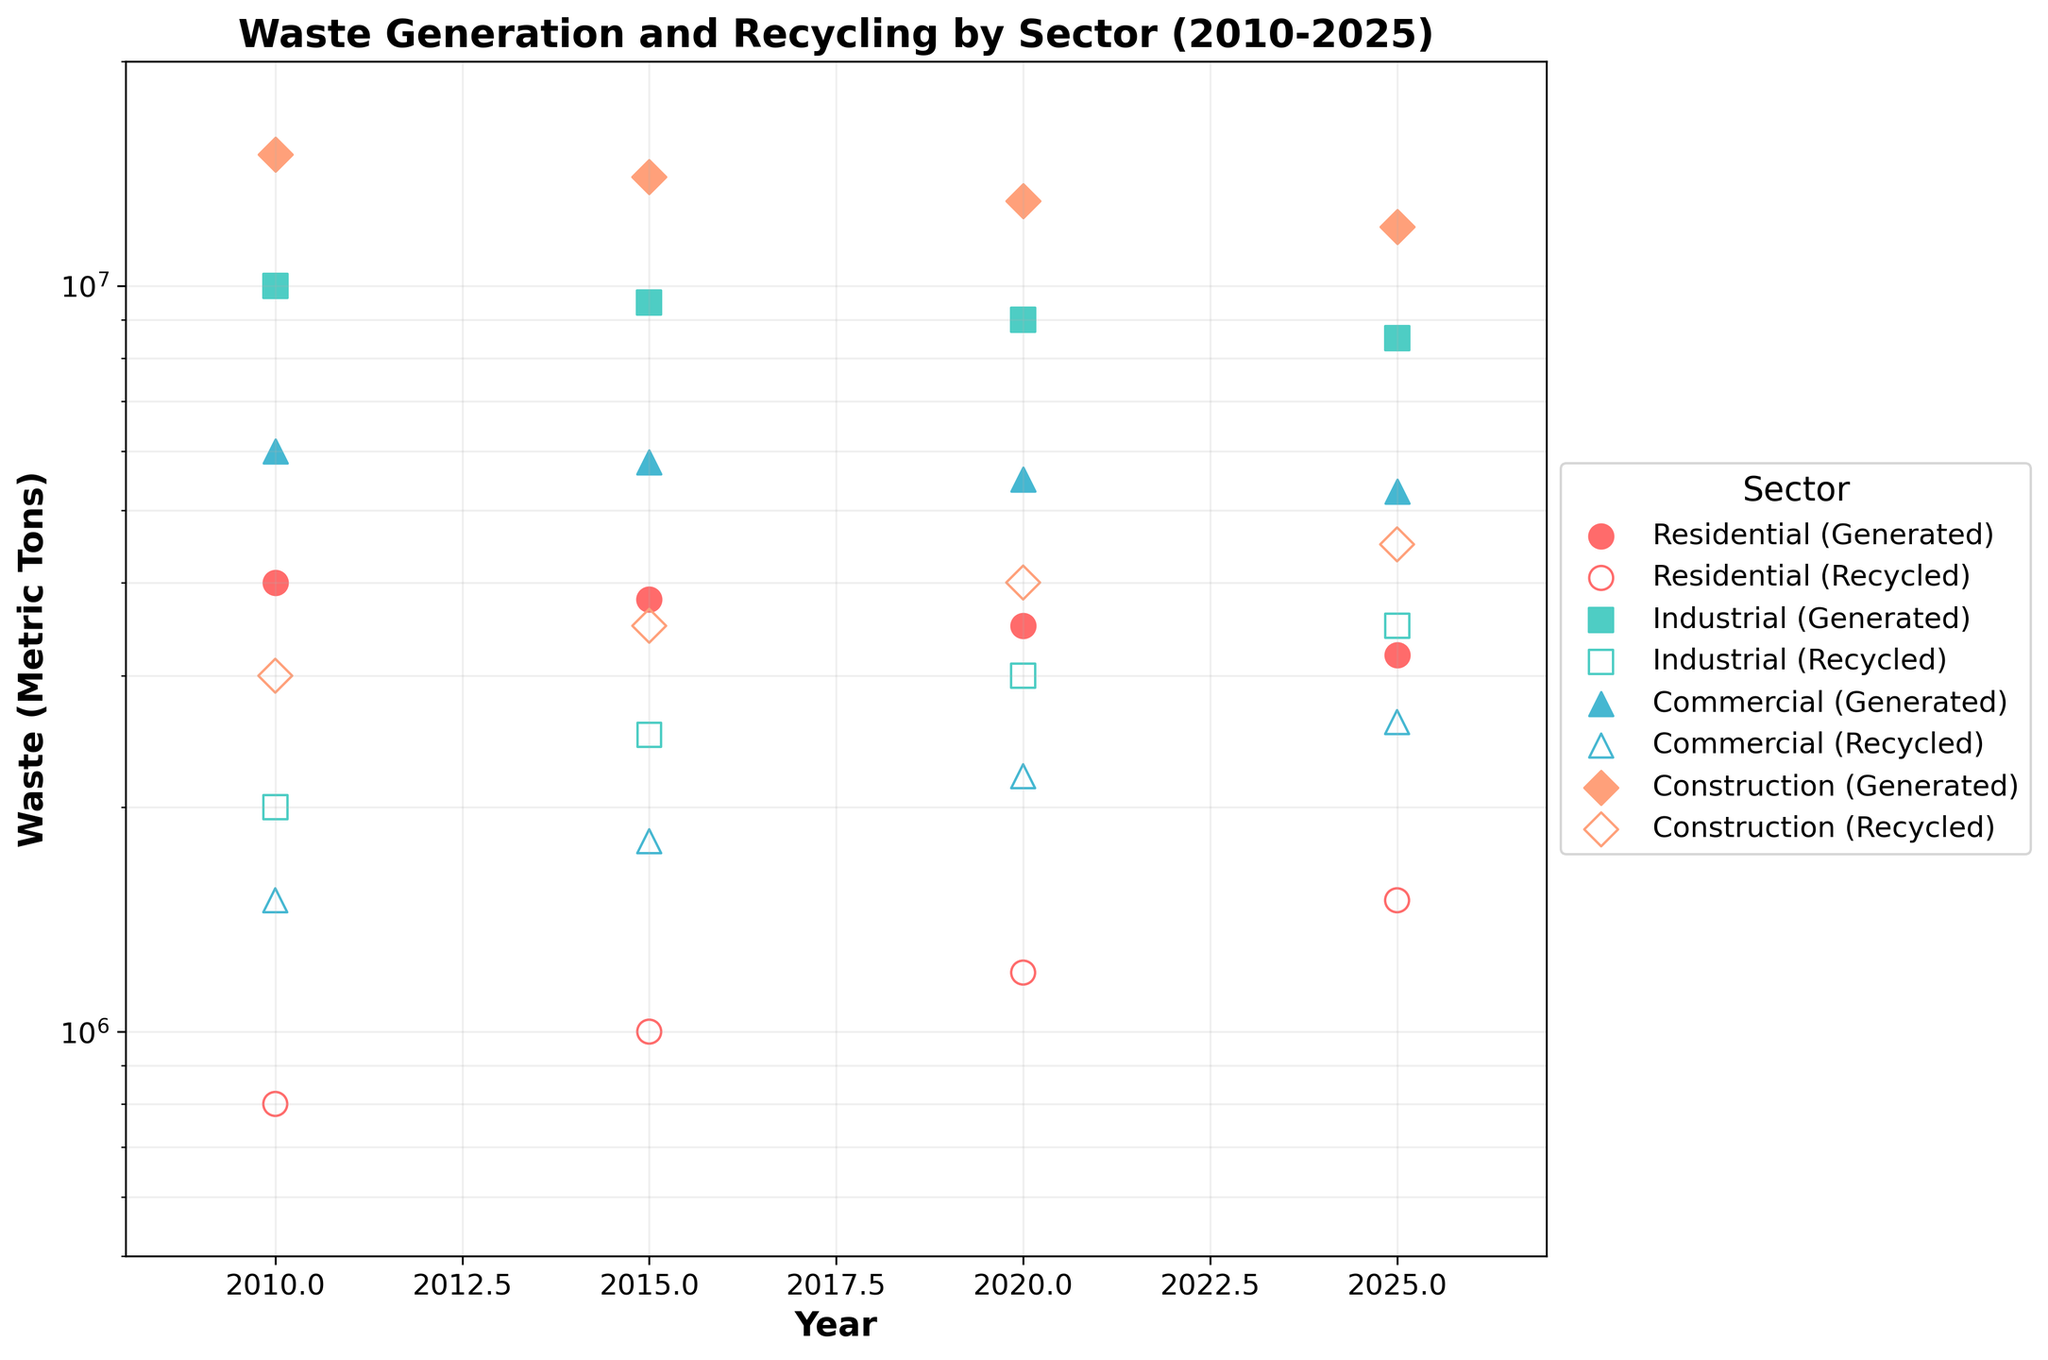How many sectors are represented in the figure? The legend contains distinct markers and colors for each sector represented. By counting these unique markers/colors in the legend, one can determine the number of sectors.
Answer: 4 Which sector generated the most waste in 2010? Check each sector's data on the x-axis for the year 2010 and observe the corresponding y-values for WasteGeneratedMetricTons. The sector with the highest y-value is identified.
Answer: Construction How does the Residential sector's waste generation in 2025 compare to 2010? Compare the y-values (WasteGeneratedMetricTons) for the Residential sector in 2025 and 2010. Specifically, observe if it increased or decreased and by how much.
Answer: Decreased by 800,000 tons Which sector shows the largest improvement in recycling from 2010 to 2025? Compute the increase in RecycledWasteMetricTons for each sector from 2010 to 2025 and find the sector with the highest difference.
Answer: Construction What's the general trend of waste generation in the Industrial sector over time? Observe the y-values for WasteGeneratedMetricTons for the Industrial sector across the years. Identify if they are generally increasing, decreasing, or stable.
Answer: Decreasing Which year had the highest total recycled waste among all sectors? Sum the RecycledWasteMetricTons values for each sector per year and determine which year has the highest total.
Answer: 2025 What is the color used to represent the Commercial sector? Check the legend in the plot to see the color associated with the Commercial sector label.
Answer: Blue (or the specified color from the color scheme) By what factor has the residential sector's recycled waste increased from 2010 to 2025? Calculate the quotient of RecycledWasteMetricTons in 2025 over 2010 for the Residential sector.
Answer: 1.875 At which year do all sectors seem to have the least generated waste? Observe the WasteGeneratedMetricTons for each sector over the years and find the year with the minimum values across all sectors.
Answer: 2025 